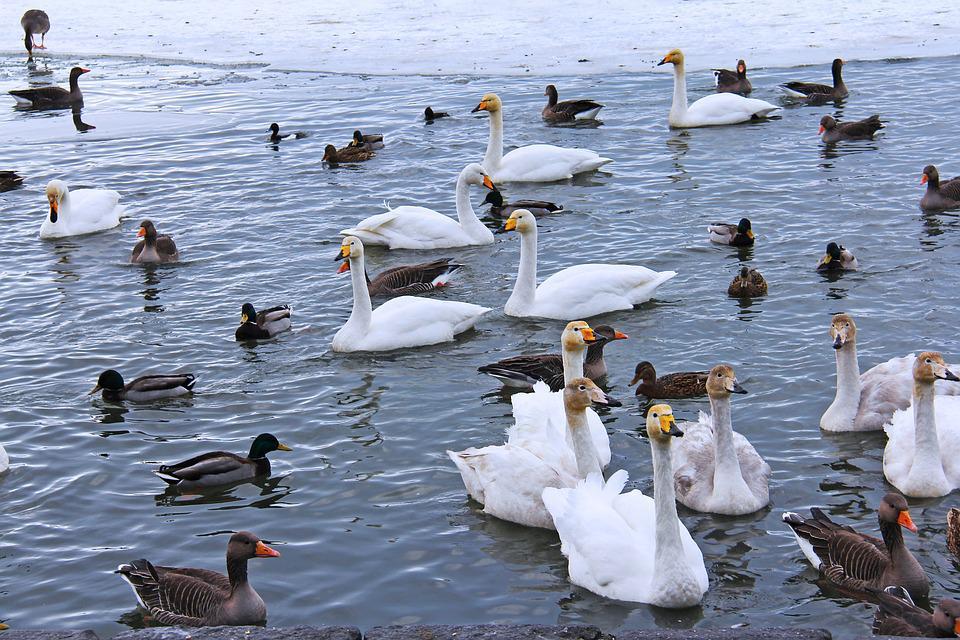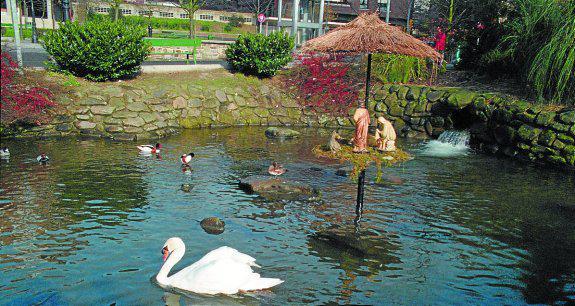The first image is the image on the left, the second image is the image on the right. For the images displayed, is the sentence "Every single image features more than one bird." factually correct? Answer yes or no. Yes. 